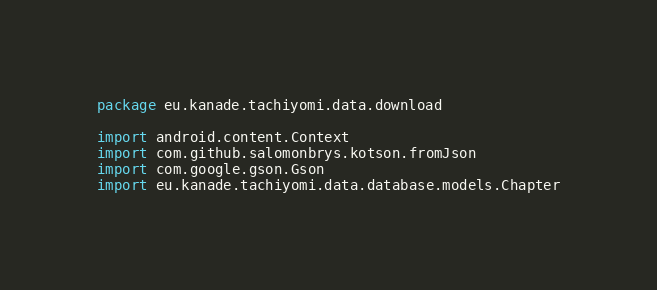Convert code to text. <code><loc_0><loc_0><loc_500><loc_500><_Kotlin_>package eu.kanade.tachiyomi.data.download

import android.content.Context
import com.github.salomonbrys.kotson.fromJson
import com.google.gson.Gson
import eu.kanade.tachiyomi.data.database.models.Chapter</code> 